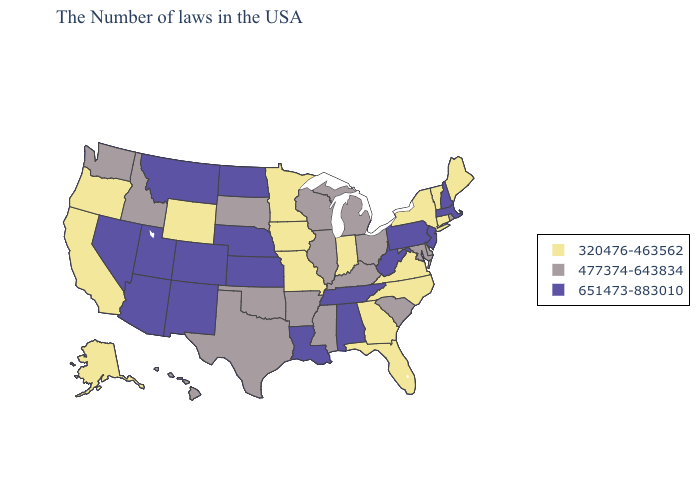Does the first symbol in the legend represent the smallest category?
Answer briefly. Yes. Among the states that border Michigan , does Ohio have the highest value?
Write a very short answer. Yes. What is the value of Idaho?
Quick response, please. 477374-643834. Does Idaho have the same value as Nevada?
Answer briefly. No. What is the highest value in the Northeast ?
Write a very short answer. 651473-883010. Name the states that have a value in the range 651473-883010?
Answer briefly. Massachusetts, New Hampshire, New Jersey, Pennsylvania, West Virginia, Alabama, Tennessee, Louisiana, Kansas, Nebraska, North Dakota, Colorado, New Mexico, Utah, Montana, Arizona, Nevada. Among the states that border Nebraska , which have the highest value?
Short answer required. Kansas, Colorado. Name the states that have a value in the range 477374-643834?
Concise answer only. Rhode Island, Delaware, Maryland, South Carolina, Ohio, Michigan, Kentucky, Wisconsin, Illinois, Mississippi, Arkansas, Oklahoma, Texas, South Dakota, Idaho, Washington, Hawaii. Does the first symbol in the legend represent the smallest category?
Concise answer only. Yes. Name the states that have a value in the range 320476-463562?
Give a very brief answer. Maine, Vermont, Connecticut, New York, Virginia, North Carolina, Florida, Georgia, Indiana, Missouri, Minnesota, Iowa, Wyoming, California, Oregon, Alaska. Name the states that have a value in the range 320476-463562?
Concise answer only. Maine, Vermont, Connecticut, New York, Virginia, North Carolina, Florida, Georgia, Indiana, Missouri, Minnesota, Iowa, Wyoming, California, Oregon, Alaska. Which states have the lowest value in the Northeast?
Give a very brief answer. Maine, Vermont, Connecticut, New York. Name the states that have a value in the range 651473-883010?
Give a very brief answer. Massachusetts, New Hampshire, New Jersey, Pennsylvania, West Virginia, Alabama, Tennessee, Louisiana, Kansas, Nebraska, North Dakota, Colorado, New Mexico, Utah, Montana, Arizona, Nevada. Name the states that have a value in the range 651473-883010?
Concise answer only. Massachusetts, New Hampshire, New Jersey, Pennsylvania, West Virginia, Alabama, Tennessee, Louisiana, Kansas, Nebraska, North Dakota, Colorado, New Mexico, Utah, Montana, Arizona, Nevada. Name the states that have a value in the range 320476-463562?
Be succinct. Maine, Vermont, Connecticut, New York, Virginia, North Carolina, Florida, Georgia, Indiana, Missouri, Minnesota, Iowa, Wyoming, California, Oregon, Alaska. 